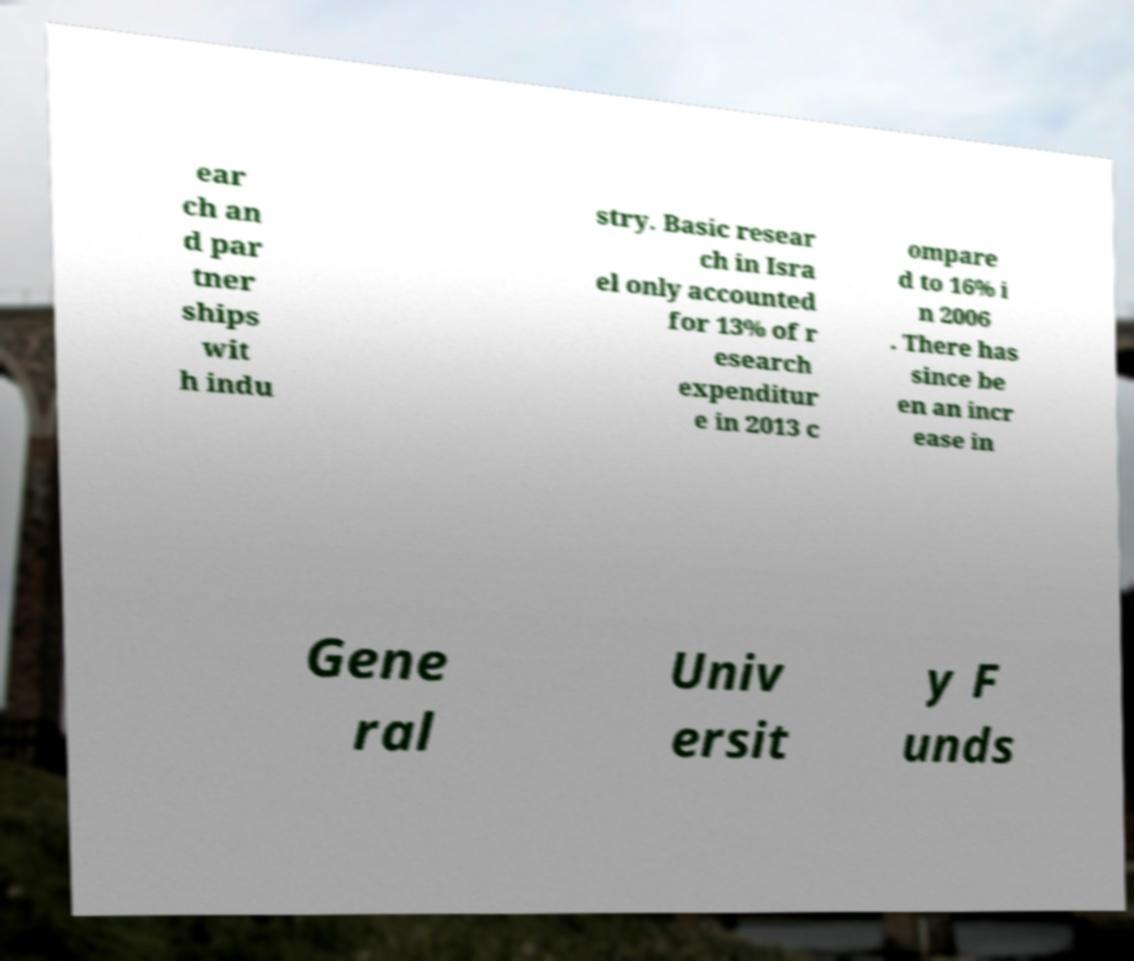Could you assist in decoding the text presented in this image and type it out clearly? ear ch an d par tner ships wit h indu stry. Basic resear ch in Isra el only accounted for 13% of r esearch expenditur e in 2013 c ompare d to 16% i n 2006 . There has since be en an incr ease in Gene ral Univ ersit y F unds 